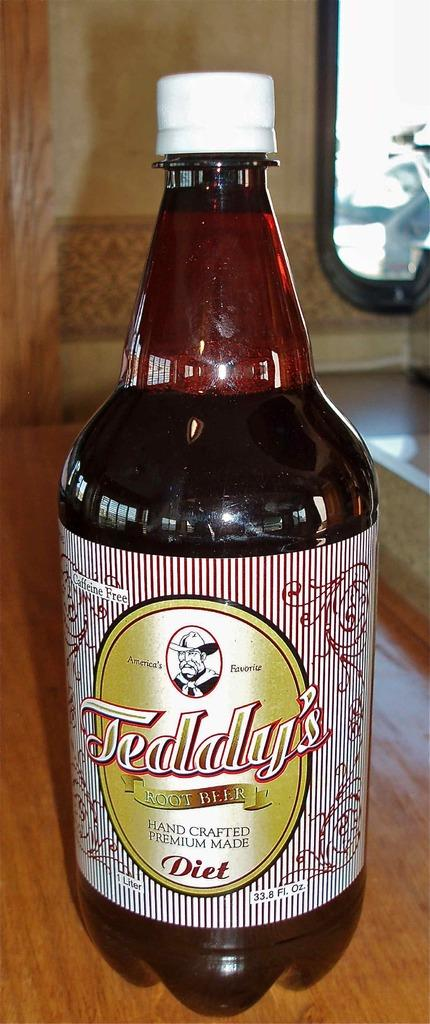What is on the bottle that is visible in the image? There is a label on the bottle in the image. Where is the bottle located in the image? The bottle is placed on a table in the image. What can be seen in the background of the image? There is a wall in the background of the image. What type of flower is growing on the wall in the image? There are no flowers visible on the wall in the image. Can you describe the ghost that is present in the image? There are no ghosts present in the image. 